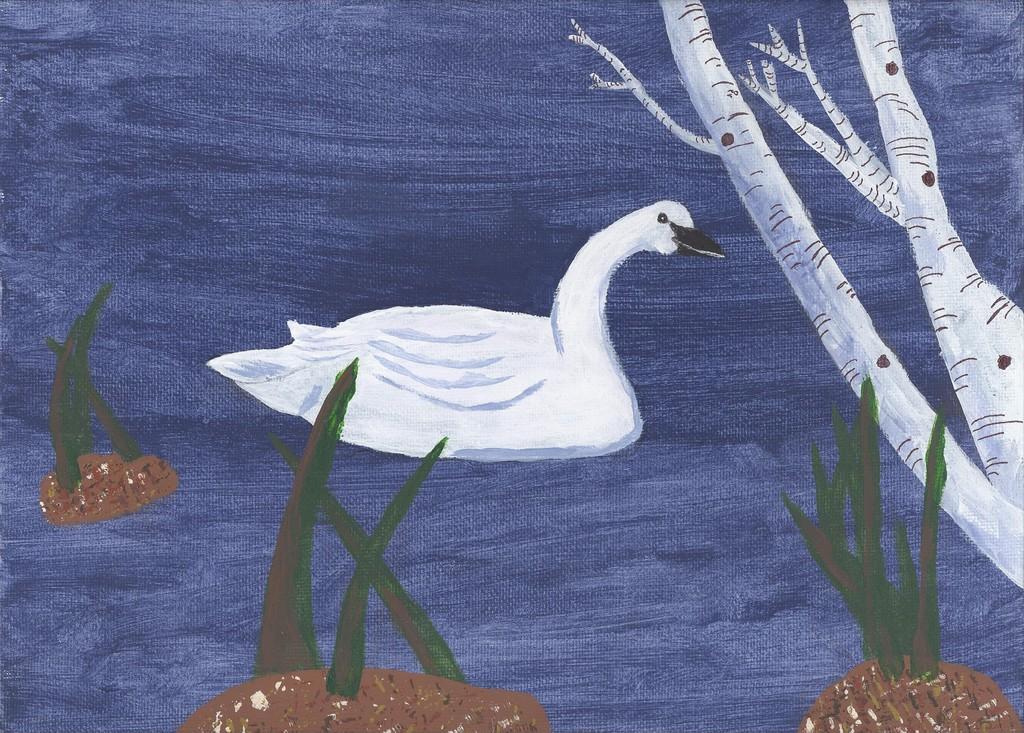Can you describe this image briefly? This is a painted image as we can see there is a picture of a swan in the middle of this image and there are some leaves and a stem of a tree at the bottom of this image. 